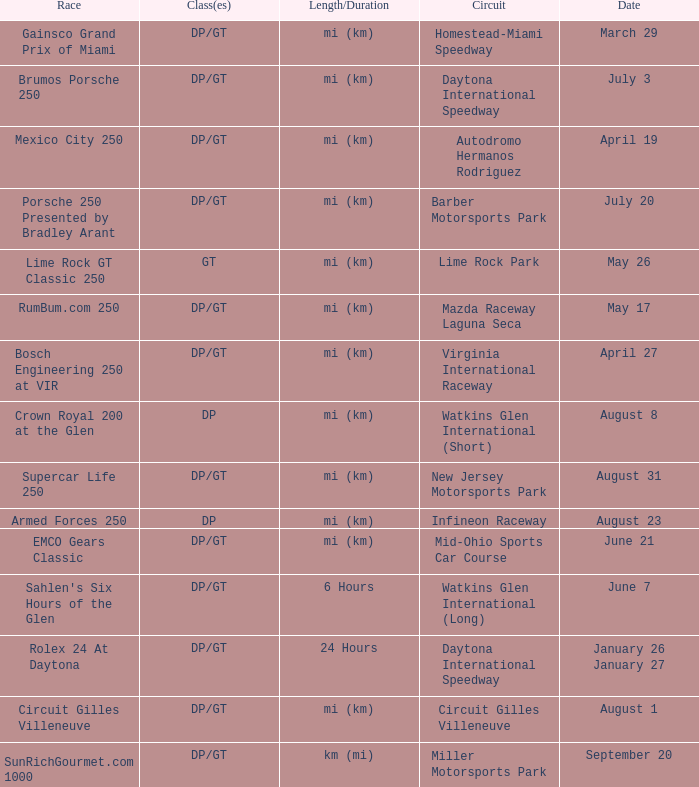What was the date of the race that lasted 6 hours? June 7. 